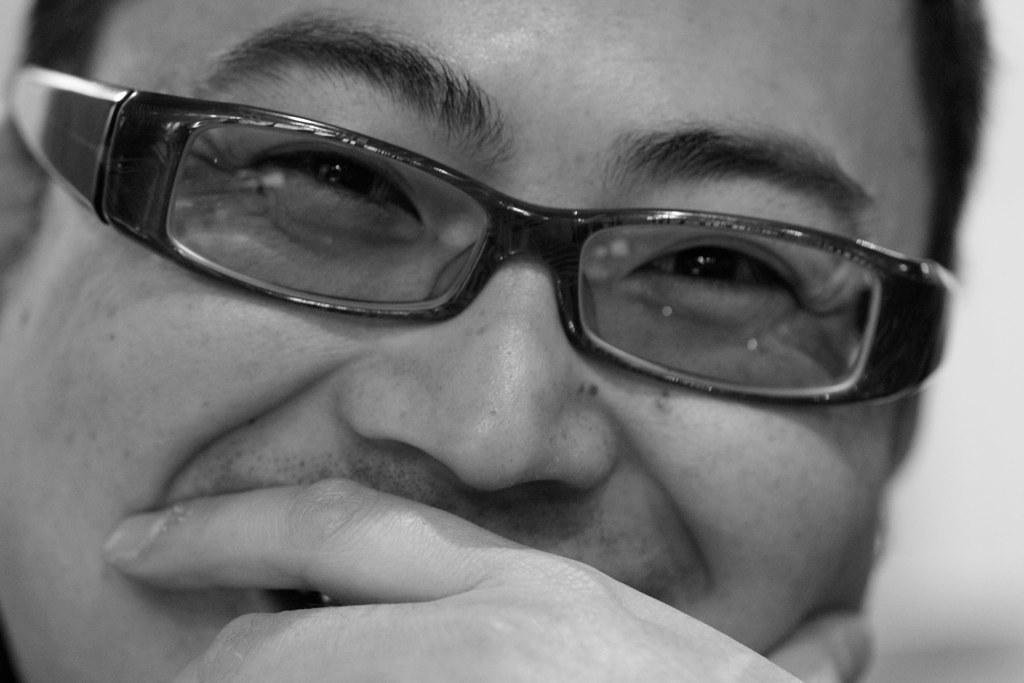In one or two sentences, can you explain what this image depicts? This is the zoomed in image of a man. He is wearing spectacles and smiling. 